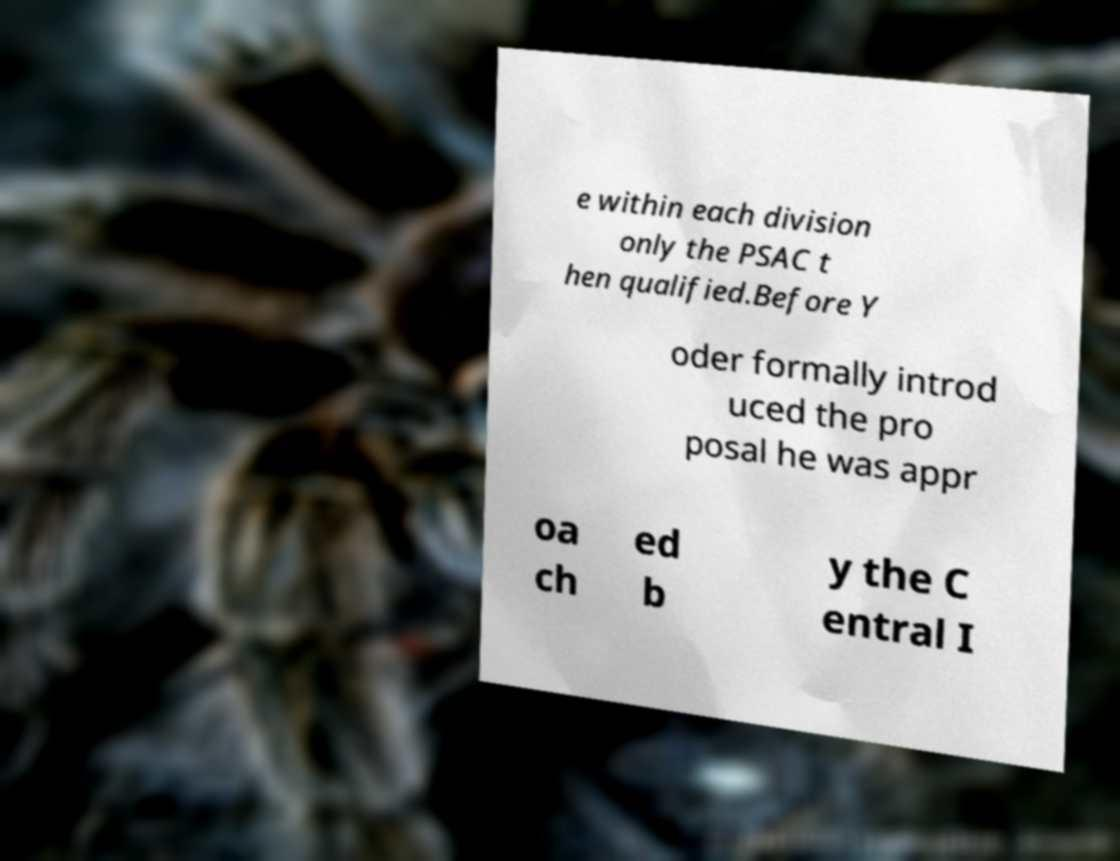Please identify and transcribe the text found in this image. e within each division only the PSAC t hen qualified.Before Y oder formally introd uced the pro posal he was appr oa ch ed b y the C entral I 